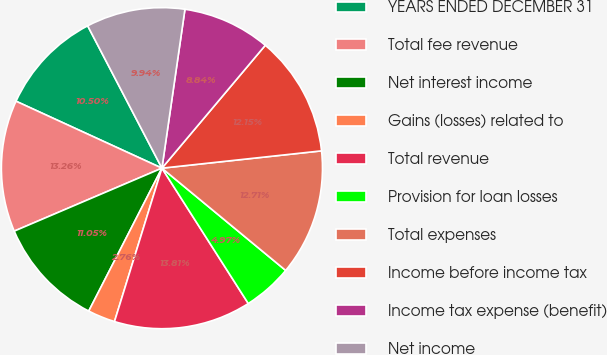Convert chart to OTSL. <chart><loc_0><loc_0><loc_500><loc_500><pie_chart><fcel>YEARS ENDED DECEMBER 31<fcel>Total fee revenue<fcel>Net interest income<fcel>Gains (losses) related to<fcel>Total revenue<fcel>Provision for loan losses<fcel>Total expenses<fcel>Income before income tax<fcel>Income tax expense (benefit)<fcel>Net income<nl><fcel>10.5%<fcel>13.26%<fcel>11.05%<fcel>2.76%<fcel>13.81%<fcel>4.97%<fcel>12.71%<fcel>12.15%<fcel>8.84%<fcel>9.94%<nl></chart> 